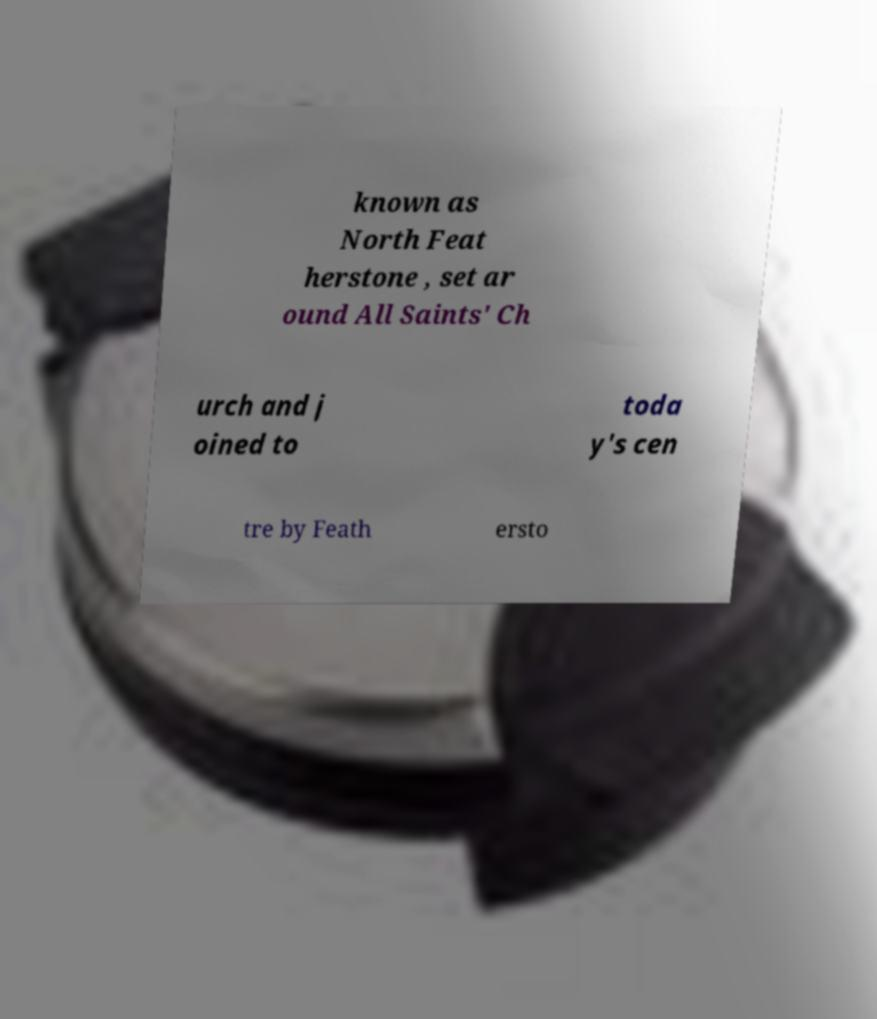There's text embedded in this image that I need extracted. Can you transcribe it verbatim? known as North Feat herstone , set ar ound All Saints' Ch urch and j oined to toda y's cen tre by Feath ersto 